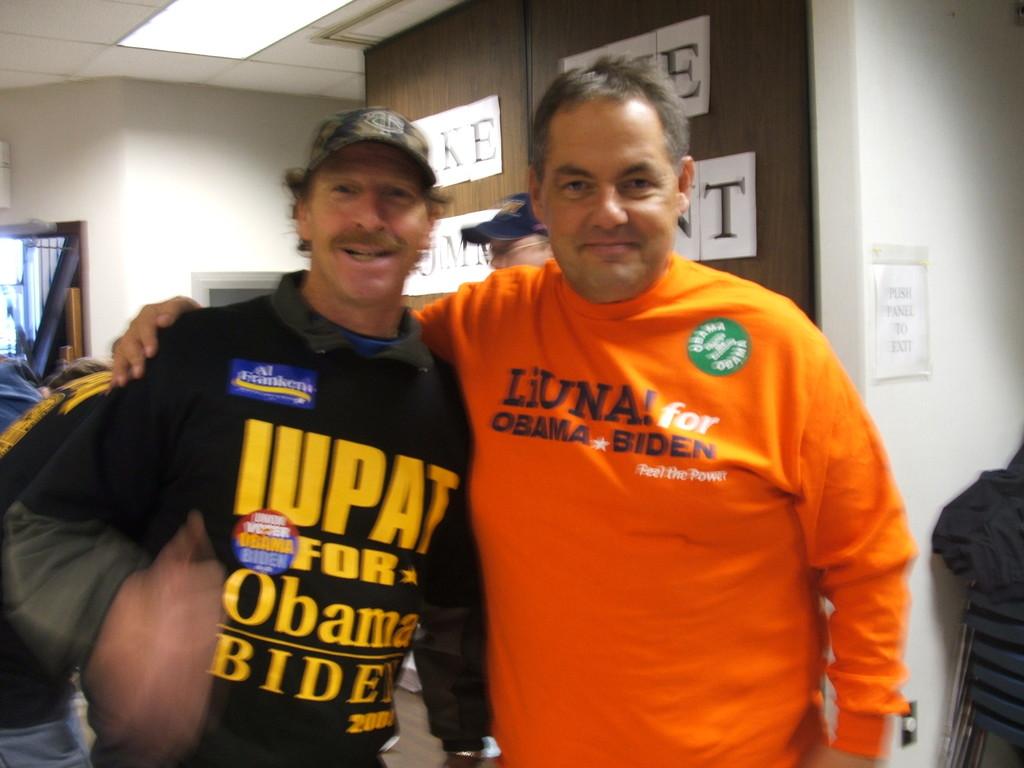What is the second name on tee men's tee shirt?
Offer a very short reply. Biden. 